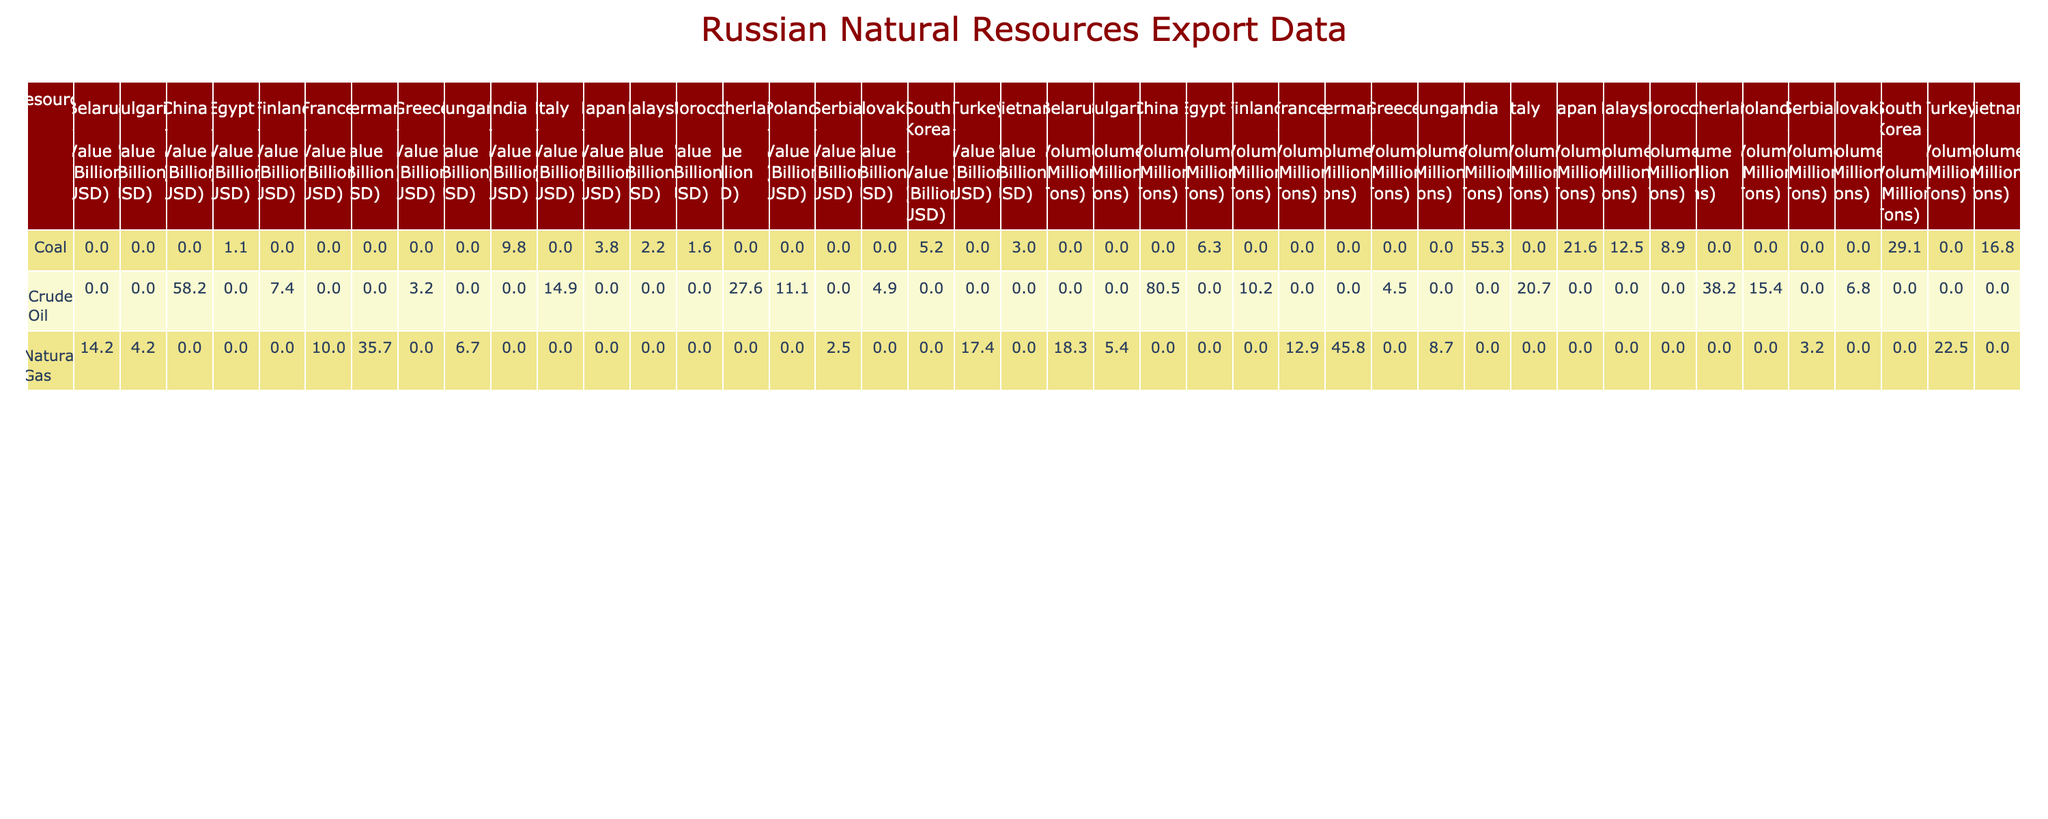What is the total volume of crude oil exported to China? Looking at the table, the volume of crude oil exported to China in 2022 is listed as 80.5 million tons. Since this is a direct retrieval question, we can simply refer to that cell in the table.
Answer: 80.5 million tons Which country received the highest volume of natural gas from Russia? To find out which country received the most natural gas, we need to compare the volumes listed under the Natural Gas category. The highest value is 45.8 million tons, which corresponds to Germany.
Answer: Germany What is the total export value of coal to all countries combined? Summing the values in the Coal row: 9.8 (India) + 5.2 (South Korea) + 3.8 (Japan) + 3.0 (Vietnam) + 1.6 (Morocco) + 2.2 (Malaysia) + 1.1 (Egypt) = 26.7 billion USD. Thus, the total export value of coal is 26.7 billion USD.
Answer: 26.7 billion USD Did Russia export more natural gas or crude oil in total? To answer this, we must sum the volumes of both resources. For natural gas: 45.8 (Germany) + 22.5 (Turkey) + 18.3 (Belarus) + 12.9 (France) + 8.7 (Hungary) + 5.4 (Bulgaria) + 3.2 (Serbia) = 117.8 million tons. For crude oil: 80.5 (China) + 38.2 (Netherlands) + 20.7 (Italy) + 15.4 (Poland) + 10.2 (Finland) + 6.8 (Slovakia) + 4.5 (Greece) = 176.3 million tons. Since 176.3 million tons is greater than 117.8 million tons, Russia exported more crude oil.
Answer: Yes, crude oil had higher exports What is the difference in export value between crude oil to China and natural gas to Germany? We compare the value of crude oil to China (58.2 billion USD) with natural gas to Germany (35.7 billion USD). To find the difference, we subtract: 58.2 - 35.7 = 22.5 billion USD.
Answer: 22.5 billion USD Is the volume of coal exported to Egypt greater than that exported to Morocco? The table shows that the volume of coal exported to Egypt is 6.3 million tons and to Morocco is 8.9 million tons. Since 8.9 million is greater than 6.3 million, the statement is false.
Answer: No What is the average volume of crude oil exported to all countries listed? We first count the number of countries that received crude oil, which are 7 in total. Then we add their volumes: 80.5 + 38.2 + 20.7 + 15.4 + 10.2 + 6.8 + 4.5 = 176.3 million tons. Finally, we divide this total by 7, which gives us an average of approximately 25.04 million tons.
Answer: 25.04 million tons Which country received the lowest volume of natural gas from Russia? By inspecting the Natural Gas figures listed, we can compare all the values for natural gas. The lowest value appears to be for Serbia at 3.2 million tons.
Answer: Serbia 